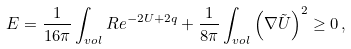<formula> <loc_0><loc_0><loc_500><loc_500>E = \frac { 1 } { 1 6 \pi } \int _ { v o l } R e ^ { - 2 U + 2 q } + \frac { 1 } { 8 \pi } \int _ { v o l } \left ( \nabla \tilde { U } \right ) ^ { 2 } \geq 0 \, ,</formula> 